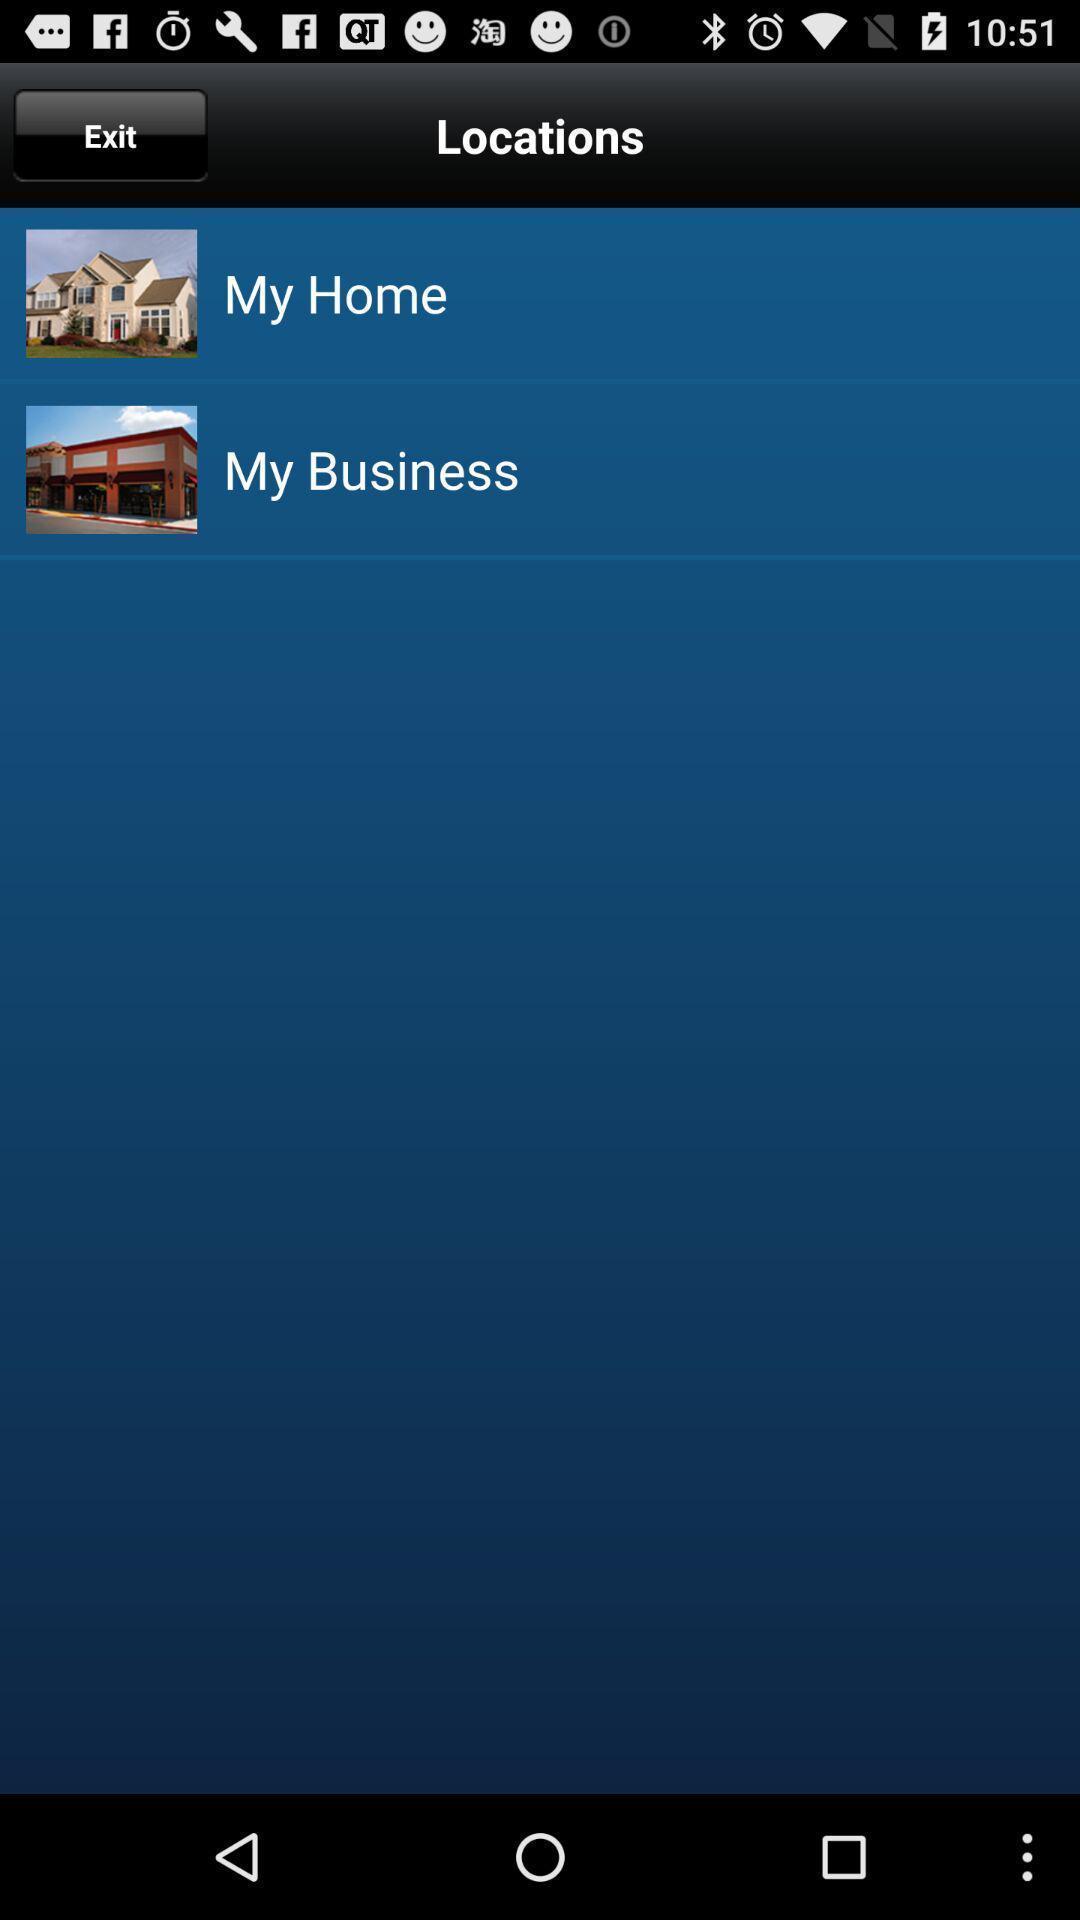Describe the key features of this screenshot. Page showing the location options. 